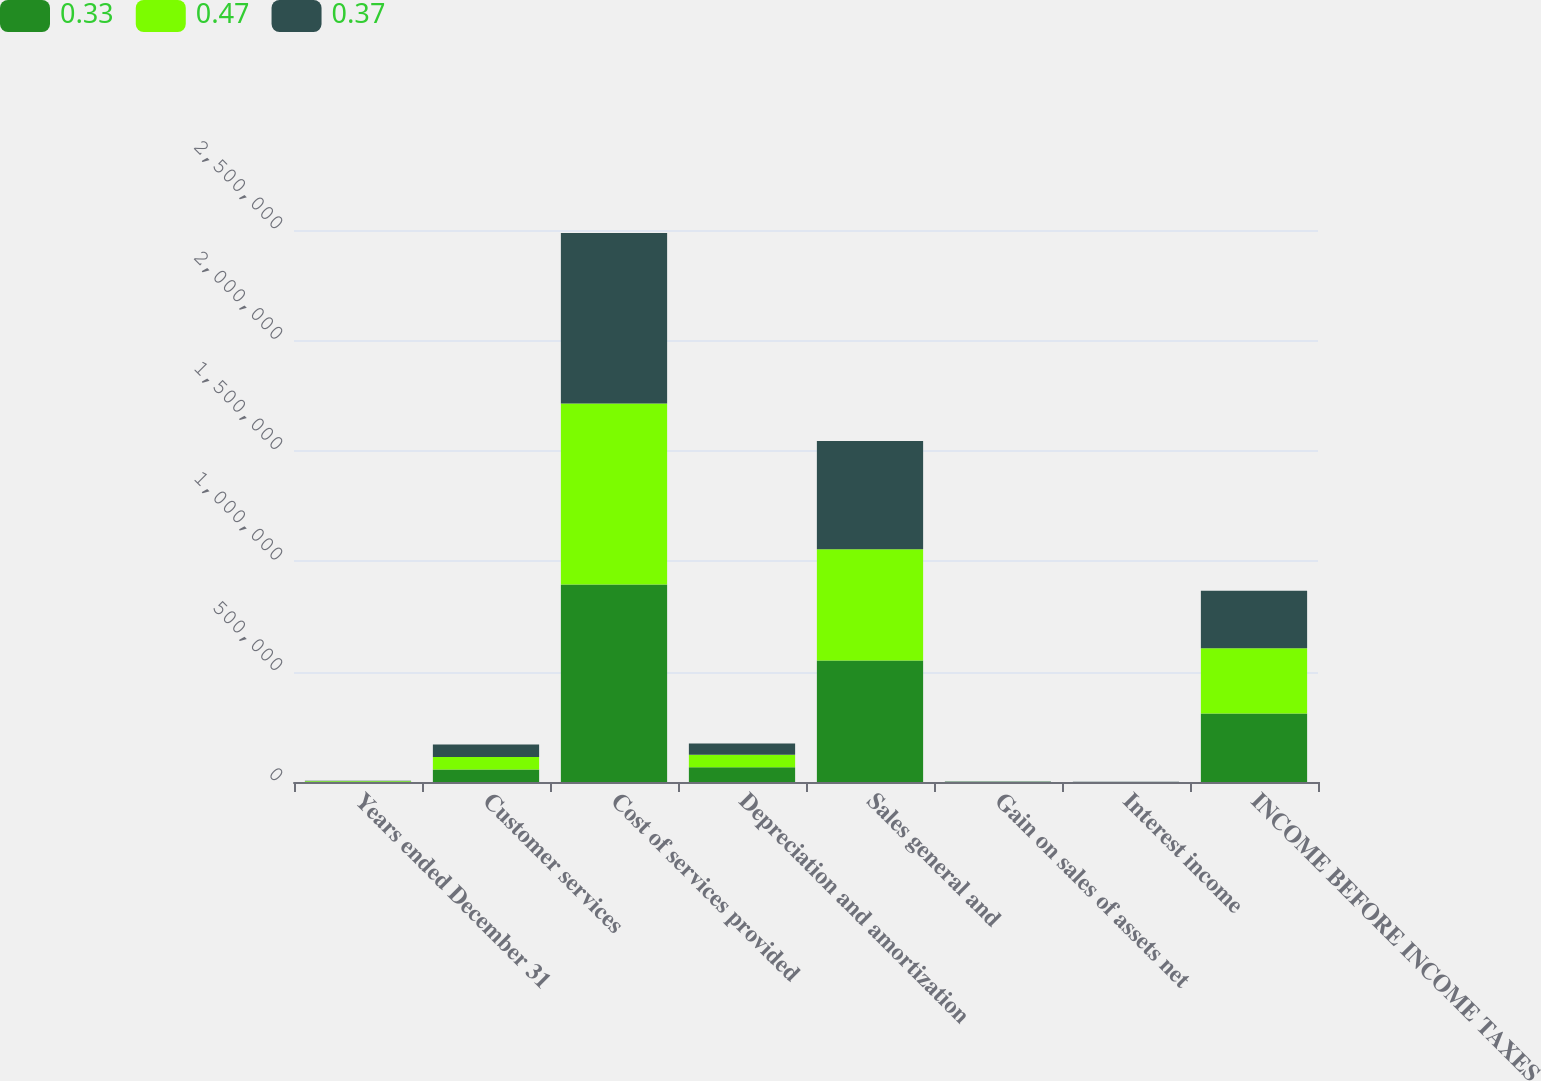Convert chart to OTSL. <chart><loc_0><loc_0><loc_500><loc_500><stacked_bar_chart><ecel><fcel>Years ended December 31<fcel>Customer services<fcel>Cost of services provided<fcel>Depreciation and amortization<fcel>Sales general and<fcel>Gain on sales of assets net<fcel>Interest income<fcel>INCOME BEFORE INCOME TAXES<nl><fcel>0.33<fcel>2018<fcel>56580<fcel>894437<fcel>66792<fcel>550698<fcel>875<fcel>220<fcel>310733<nl><fcel>0.47<fcel>2017<fcel>56580<fcel>819943<fcel>56580<fcel>503433<fcel>242<fcel>259<fcel>294502<nl><fcel>0.37<fcel>2016<fcel>56580<fcel>772348<fcel>50902<fcel>490528<fcel>777<fcel>160<fcel>260636<nl></chart> 